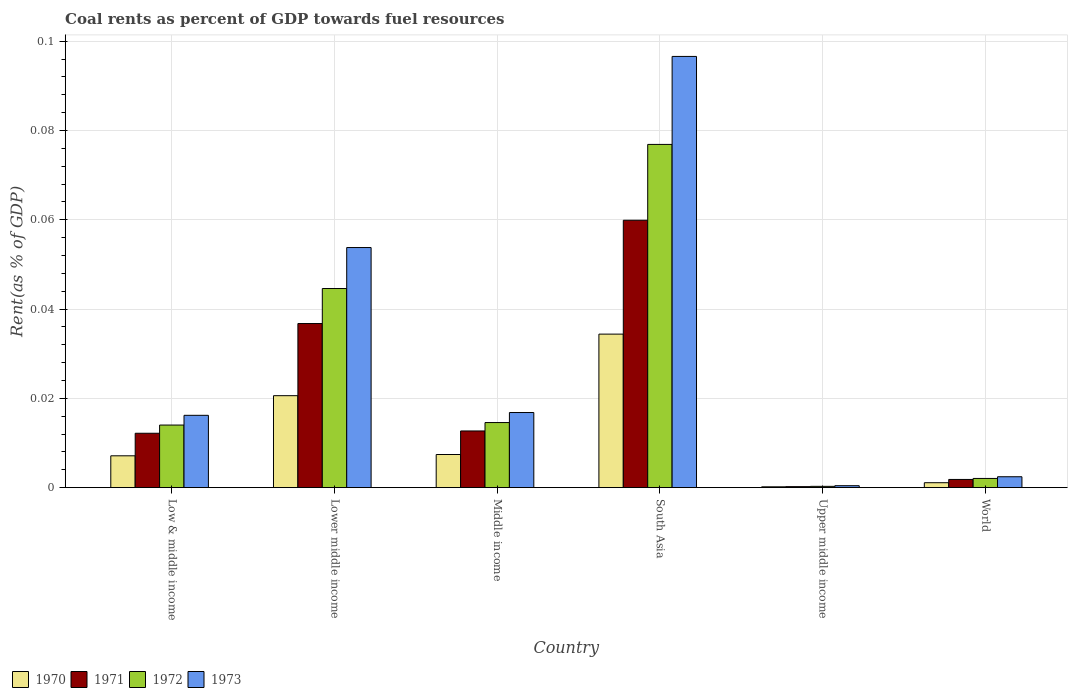How many groups of bars are there?
Offer a terse response. 6. Are the number of bars per tick equal to the number of legend labels?
Offer a very short reply. Yes. How many bars are there on the 3rd tick from the left?
Make the answer very short. 4. What is the label of the 5th group of bars from the left?
Ensure brevity in your answer.  Upper middle income. What is the coal rent in 1973 in South Asia?
Give a very brief answer. 0.1. Across all countries, what is the maximum coal rent in 1971?
Your answer should be very brief. 0.06. Across all countries, what is the minimum coal rent in 1972?
Keep it short and to the point. 0. In which country was the coal rent in 1970 minimum?
Offer a very short reply. Upper middle income. What is the total coal rent in 1973 in the graph?
Provide a succinct answer. 0.19. What is the difference between the coal rent in 1971 in Middle income and that in South Asia?
Provide a succinct answer. -0.05. What is the difference between the coal rent in 1973 in Lower middle income and the coal rent in 1970 in World?
Your answer should be very brief. 0.05. What is the average coal rent in 1973 per country?
Provide a succinct answer. 0.03. What is the difference between the coal rent of/in 1973 and coal rent of/in 1970 in Low & middle income?
Your answer should be very brief. 0.01. In how many countries, is the coal rent in 1971 greater than 0.08 %?
Your answer should be very brief. 0. What is the ratio of the coal rent in 1970 in Low & middle income to that in Lower middle income?
Make the answer very short. 0.35. Is the coal rent in 1972 in Lower middle income less than that in Upper middle income?
Give a very brief answer. No. What is the difference between the highest and the second highest coal rent in 1970?
Your response must be concise. 0.01. What is the difference between the highest and the lowest coal rent in 1971?
Your response must be concise. 0.06. Is the sum of the coal rent in 1970 in Lower middle income and South Asia greater than the maximum coal rent in 1973 across all countries?
Give a very brief answer. No. Is it the case that in every country, the sum of the coal rent in 1971 and coal rent in 1972 is greater than the sum of coal rent in 1970 and coal rent in 1973?
Give a very brief answer. No. What does the 1st bar from the right in South Asia represents?
Offer a terse response. 1973. How many bars are there?
Keep it short and to the point. 24. How many countries are there in the graph?
Your response must be concise. 6. What is the difference between two consecutive major ticks on the Y-axis?
Your answer should be very brief. 0.02. Does the graph contain any zero values?
Provide a short and direct response. No. Where does the legend appear in the graph?
Your answer should be very brief. Bottom left. How many legend labels are there?
Your answer should be very brief. 4. How are the legend labels stacked?
Give a very brief answer. Horizontal. What is the title of the graph?
Your answer should be very brief. Coal rents as percent of GDP towards fuel resources. What is the label or title of the Y-axis?
Your answer should be very brief. Rent(as % of GDP). What is the Rent(as % of GDP) of 1970 in Low & middle income?
Keep it short and to the point. 0.01. What is the Rent(as % of GDP) of 1971 in Low & middle income?
Offer a very short reply. 0.01. What is the Rent(as % of GDP) in 1972 in Low & middle income?
Your answer should be very brief. 0.01. What is the Rent(as % of GDP) in 1973 in Low & middle income?
Offer a very short reply. 0.02. What is the Rent(as % of GDP) in 1970 in Lower middle income?
Offer a very short reply. 0.02. What is the Rent(as % of GDP) in 1971 in Lower middle income?
Provide a short and direct response. 0.04. What is the Rent(as % of GDP) of 1972 in Lower middle income?
Provide a short and direct response. 0.04. What is the Rent(as % of GDP) in 1973 in Lower middle income?
Keep it short and to the point. 0.05. What is the Rent(as % of GDP) in 1970 in Middle income?
Give a very brief answer. 0.01. What is the Rent(as % of GDP) of 1971 in Middle income?
Your answer should be very brief. 0.01. What is the Rent(as % of GDP) in 1972 in Middle income?
Make the answer very short. 0.01. What is the Rent(as % of GDP) in 1973 in Middle income?
Keep it short and to the point. 0.02. What is the Rent(as % of GDP) of 1970 in South Asia?
Make the answer very short. 0.03. What is the Rent(as % of GDP) in 1971 in South Asia?
Make the answer very short. 0.06. What is the Rent(as % of GDP) in 1972 in South Asia?
Ensure brevity in your answer.  0.08. What is the Rent(as % of GDP) of 1973 in South Asia?
Your answer should be very brief. 0.1. What is the Rent(as % of GDP) in 1970 in Upper middle income?
Your answer should be very brief. 0. What is the Rent(as % of GDP) of 1971 in Upper middle income?
Offer a very short reply. 0. What is the Rent(as % of GDP) of 1972 in Upper middle income?
Provide a short and direct response. 0. What is the Rent(as % of GDP) of 1973 in Upper middle income?
Offer a terse response. 0. What is the Rent(as % of GDP) of 1970 in World?
Your response must be concise. 0. What is the Rent(as % of GDP) of 1971 in World?
Ensure brevity in your answer.  0. What is the Rent(as % of GDP) in 1972 in World?
Provide a succinct answer. 0. What is the Rent(as % of GDP) in 1973 in World?
Make the answer very short. 0. Across all countries, what is the maximum Rent(as % of GDP) of 1970?
Your response must be concise. 0.03. Across all countries, what is the maximum Rent(as % of GDP) in 1971?
Provide a short and direct response. 0.06. Across all countries, what is the maximum Rent(as % of GDP) of 1972?
Offer a very short reply. 0.08. Across all countries, what is the maximum Rent(as % of GDP) in 1973?
Keep it short and to the point. 0.1. Across all countries, what is the minimum Rent(as % of GDP) in 1970?
Give a very brief answer. 0. Across all countries, what is the minimum Rent(as % of GDP) in 1971?
Ensure brevity in your answer.  0. Across all countries, what is the minimum Rent(as % of GDP) of 1972?
Provide a succinct answer. 0. Across all countries, what is the minimum Rent(as % of GDP) of 1973?
Offer a very short reply. 0. What is the total Rent(as % of GDP) of 1970 in the graph?
Provide a succinct answer. 0.07. What is the total Rent(as % of GDP) in 1971 in the graph?
Offer a terse response. 0.12. What is the total Rent(as % of GDP) in 1972 in the graph?
Your answer should be compact. 0.15. What is the total Rent(as % of GDP) of 1973 in the graph?
Provide a short and direct response. 0.19. What is the difference between the Rent(as % of GDP) of 1970 in Low & middle income and that in Lower middle income?
Offer a very short reply. -0.01. What is the difference between the Rent(as % of GDP) in 1971 in Low & middle income and that in Lower middle income?
Ensure brevity in your answer.  -0.02. What is the difference between the Rent(as % of GDP) in 1972 in Low & middle income and that in Lower middle income?
Keep it short and to the point. -0.03. What is the difference between the Rent(as % of GDP) in 1973 in Low & middle income and that in Lower middle income?
Provide a short and direct response. -0.04. What is the difference between the Rent(as % of GDP) in 1970 in Low & middle income and that in Middle income?
Offer a very short reply. -0. What is the difference between the Rent(as % of GDP) of 1971 in Low & middle income and that in Middle income?
Provide a succinct answer. -0. What is the difference between the Rent(as % of GDP) in 1972 in Low & middle income and that in Middle income?
Provide a short and direct response. -0. What is the difference between the Rent(as % of GDP) of 1973 in Low & middle income and that in Middle income?
Your response must be concise. -0. What is the difference between the Rent(as % of GDP) in 1970 in Low & middle income and that in South Asia?
Give a very brief answer. -0.03. What is the difference between the Rent(as % of GDP) in 1971 in Low & middle income and that in South Asia?
Give a very brief answer. -0.05. What is the difference between the Rent(as % of GDP) of 1972 in Low & middle income and that in South Asia?
Offer a terse response. -0.06. What is the difference between the Rent(as % of GDP) of 1973 in Low & middle income and that in South Asia?
Offer a terse response. -0.08. What is the difference between the Rent(as % of GDP) of 1970 in Low & middle income and that in Upper middle income?
Offer a terse response. 0.01. What is the difference between the Rent(as % of GDP) of 1971 in Low & middle income and that in Upper middle income?
Keep it short and to the point. 0.01. What is the difference between the Rent(as % of GDP) of 1972 in Low & middle income and that in Upper middle income?
Offer a very short reply. 0.01. What is the difference between the Rent(as % of GDP) in 1973 in Low & middle income and that in Upper middle income?
Make the answer very short. 0.02. What is the difference between the Rent(as % of GDP) in 1970 in Low & middle income and that in World?
Your response must be concise. 0.01. What is the difference between the Rent(as % of GDP) of 1971 in Low & middle income and that in World?
Offer a terse response. 0.01. What is the difference between the Rent(as % of GDP) of 1972 in Low & middle income and that in World?
Offer a very short reply. 0.01. What is the difference between the Rent(as % of GDP) in 1973 in Low & middle income and that in World?
Keep it short and to the point. 0.01. What is the difference between the Rent(as % of GDP) in 1970 in Lower middle income and that in Middle income?
Ensure brevity in your answer.  0.01. What is the difference between the Rent(as % of GDP) in 1971 in Lower middle income and that in Middle income?
Provide a succinct answer. 0.02. What is the difference between the Rent(as % of GDP) in 1972 in Lower middle income and that in Middle income?
Keep it short and to the point. 0.03. What is the difference between the Rent(as % of GDP) in 1973 in Lower middle income and that in Middle income?
Ensure brevity in your answer.  0.04. What is the difference between the Rent(as % of GDP) of 1970 in Lower middle income and that in South Asia?
Provide a succinct answer. -0.01. What is the difference between the Rent(as % of GDP) in 1971 in Lower middle income and that in South Asia?
Give a very brief answer. -0.02. What is the difference between the Rent(as % of GDP) in 1972 in Lower middle income and that in South Asia?
Your answer should be very brief. -0.03. What is the difference between the Rent(as % of GDP) of 1973 in Lower middle income and that in South Asia?
Offer a very short reply. -0.04. What is the difference between the Rent(as % of GDP) of 1970 in Lower middle income and that in Upper middle income?
Offer a terse response. 0.02. What is the difference between the Rent(as % of GDP) of 1971 in Lower middle income and that in Upper middle income?
Make the answer very short. 0.04. What is the difference between the Rent(as % of GDP) in 1972 in Lower middle income and that in Upper middle income?
Make the answer very short. 0.04. What is the difference between the Rent(as % of GDP) in 1973 in Lower middle income and that in Upper middle income?
Provide a short and direct response. 0.05. What is the difference between the Rent(as % of GDP) in 1970 in Lower middle income and that in World?
Your response must be concise. 0.02. What is the difference between the Rent(as % of GDP) in 1971 in Lower middle income and that in World?
Keep it short and to the point. 0.03. What is the difference between the Rent(as % of GDP) in 1972 in Lower middle income and that in World?
Your answer should be very brief. 0.04. What is the difference between the Rent(as % of GDP) in 1973 in Lower middle income and that in World?
Your answer should be very brief. 0.05. What is the difference between the Rent(as % of GDP) of 1970 in Middle income and that in South Asia?
Keep it short and to the point. -0.03. What is the difference between the Rent(as % of GDP) of 1971 in Middle income and that in South Asia?
Provide a short and direct response. -0.05. What is the difference between the Rent(as % of GDP) of 1972 in Middle income and that in South Asia?
Your response must be concise. -0.06. What is the difference between the Rent(as % of GDP) in 1973 in Middle income and that in South Asia?
Offer a terse response. -0.08. What is the difference between the Rent(as % of GDP) in 1970 in Middle income and that in Upper middle income?
Keep it short and to the point. 0.01. What is the difference between the Rent(as % of GDP) of 1971 in Middle income and that in Upper middle income?
Your answer should be very brief. 0.01. What is the difference between the Rent(as % of GDP) in 1972 in Middle income and that in Upper middle income?
Give a very brief answer. 0.01. What is the difference between the Rent(as % of GDP) of 1973 in Middle income and that in Upper middle income?
Your answer should be very brief. 0.02. What is the difference between the Rent(as % of GDP) in 1970 in Middle income and that in World?
Ensure brevity in your answer.  0.01. What is the difference between the Rent(as % of GDP) in 1971 in Middle income and that in World?
Provide a short and direct response. 0.01. What is the difference between the Rent(as % of GDP) in 1972 in Middle income and that in World?
Keep it short and to the point. 0.01. What is the difference between the Rent(as % of GDP) in 1973 in Middle income and that in World?
Keep it short and to the point. 0.01. What is the difference between the Rent(as % of GDP) in 1970 in South Asia and that in Upper middle income?
Offer a very short reply. 0.03. What is the difference between the Rent(as % of GDP) in 1971 in South Asia and that in Upper middle income?
Your answer should be very brief. 0.06. What is the difference between the Rent(as % of GDP) of 1972 in South Asia and that in Upper middle income?
Offer a terse response. 0.08. What is the difference between the Rent(as % of GDP) in 1973 in South Asia and that in Upper middle income?
Provide a succinct answer. 0.1. What is the difference between the Rent(as % of GDP) in 1971 in South Asia and that in World?
Provide a succinct answer. 0.06. What is the difference between the Rent(as % of GDP) in 1972 in South Asia and that in World?
Provide a short and direct response. 0.07. What is the difference between the Rent(as % of GDP) of 1973 in South Asia and that in World?
Offer a terse response. 0.09. What is the difference between the Rent(as % of GDP) of 1970 in Upper middle income and that in World?
Your answer should be very brief. -0. What is the difference between the Rent(as % of GDP) of 1971 in Upper middle income and that in World?
Keep it short and to the point. -0. What is the difference between the Rent(as % of GDP) in 1972 in Upper middle income and that in World?
Provide a succinct answer. -0. What is the difference between the Rent(as % of GDP) of 1973 in Upper middle income and that in World?
Your answer should be very brief. -0. What is the difference between the Rent(as % of GDP) of 1970 in Low & middle income and the Rent(as % of GDP) of 1971 in Lower middle income?
Your answer should be compact. -0.03. What is the difference between the Rent(as % of GDP) of 1970 in Low & middle income and the Rent(as % of GDP) of 1972 in Lower middle income?
Give a very brief answer. -0.04. What is the difference between the Rent(as % of GDP) in 1970 in Low & middle income and the Rent(as % of GDP) in 1973 in Lower middle income?
Offer a very short reply. -0.05. What is the difference between the Rent(as % of GDP) in 1971 in Low & middle income and the Rent(as % of GDP) in 1972 in Lower middle income?
Your response must be concise. -0.03. What is the difference between the Rent(as % of GDP) of 1971 in Low & middle income and the Rent(as % of GDP) of 1973 in Lower middle income?
Ensure brevity in your answer.  -0.04. What is the difference between the Rent(as % of GDP) in 1972 in Low & middle income and the Rent(as % of GDP) in 1973 in Lower middle income?
Provide a short and direct response. -0.04. What is the difference between the Rent(as % of GDP) of 1970 in Low & middle income and the Rent(as % of GDP) of 1971 in Middle income?
Your response must be concise. -0.01. What is the difference between the Rent(as % of GDP) of 1970 in Low & middle income and the Rent(as % of GDP) of 1972 in Middle income?
Provide a short and direct response. -0.01. What is the difference between the Rent(as % of GDP) of 1970 in Low & middle income and the Rent(as % of GDP) of 1973 in Middle income?
Offer a terse response. -0.01. What is the difference between the Rent(as % of GDP) of 1971 in Low & middle income and the Rent(as % of GDP) of 1972 in Middle income?
Offer a very short reply. -0. What is the difference between the Rent(as % of GDP) of 1971 in Low & middle income and the Rent(as % of GDP) of 1973 in Middle income?
Your answer should be very brief. -0. What is the difference between the Rent(as % of GDP) in 1972 in Low & middle income and the Rent(as % of GDP) in 1973 in Middle income?
Make the answer very short. -0. What is the difference between the Rent(as % of GDP) in 1970 in Low & middle income and the Rent(as % of GDP) in 1971 in South Asia?
Offer a terse response. -0.05. What is the difference between the Rent(as % of GDP) in 1970 in Low & middle income and the Rent(as % of GDP) in 1972 in South Asia?
Ensure brevity in your answer.  -0.07. What is the difference between the Rent(as % of GDP) in 1970 in Low & middle income and the Rent(as % of GDP) in 1973 in South Asia?
Keep it short and to the point. -0.09. What is the difference between the Rent(as % of GDP) of 1971 in Low & middle income and the Rent(as % of GDP) of 1972 in South Asia?
Make the answer very short. -0.06. What is the difference between the Rent(as % of GDP) of 1971 in Low & middle income and the Rent(as % of GDP) of 1973 in South Asia?
Give a very brief answer. -0.08. What is the difference between the Rent(as % of GDP) in 1972 in Low & middle income and the Rent(as % of GDP) in 1973 in South Asia?
Provide a succinct answer. -0.08. What is the difference between the Rent(as % of GDP) of 1970 in Low & middle income and the Rent(as % of GDP) of 1971 in Upper middle income?
Provide a succinct answer. 0.01. What is the difference between the Rent(as % of GDP) of 1970 in Low & middle income and the Rent(as % of GDP) of 1972 in Upper middle income?
Your answer should be very brief. 0.01. What is the difference between the Rent(as % of GDP) in 1970 in Low & middle income and the Rent(as % of GDP) in 1973 in Upper middle income?
Keep it short and to the point. 0.01. What is the difference between the Rent(as % of GDP) of 1971 in Low & middle income and the Rent(as % of GDP) of 1972 in Upper middle income?
Ensure brevity in your answer.  0.01. What is the difference between the Rent(as % of GDP) of 1971 in Low & middle income and the Rent(as % of GDP) of 1973 in Upper middle income?
Ensure brevity in your answer.  0.01. What is the difference between the Rent(as % of GDP) in 1972 in Low & middle income and the Rent(as % of GDP) in 1973 in Upper middle income?
Offer a very short reply. 0.01. What is the difference between the Rent(as % of GDP) in 1970 in Low & middle income and the Rent(as % of GDP) in 1971 in World?
Your answer should be compact. 0.01. What is the difference between the Rent(as % of GDP) of 1970 in Low & middle income and the Rent(as % of GDP) of 1972 in World?
Make the answer very short. 0.01. What is the difference between the Rent(as % of GDP) in 1970 in Low & middle income and the Rent(as % of GDP) in 1973 in World?
Offer a very short reply. 0. What is the difference between the Rent(as % of GDP) of 1971 in Low & middle income and the Rent(as % of GDP) of 1972 in World?
Offer a terse response. 0.01. What is the difference between the Rent(as % of GDP) of 1971 in Low & middle income and the Rent(as % of GDP) of 1973 in World?
Offer a very short reply. 0.01. What is the difference between the Rent(as % of GDP) of 1972 in Low & middle income and the Rent(as % of GDP) of 1973 in World?
Your response must be concise. 0.01. What is the difference between the Rent(as % of GDP) in 1970 in Lower middle income and the Rent(as % of GDP) in 1971 in Middle income?
Your answer should be compact. 0.01. What is the difference between the Rent(as % of GDP) of 1970 in Lower middle income and the Rent(as % of GDP) of 1972 in Middle income?
Provide a succinct answer. 0.01. What is the difference between the Rent(as % of GDP) in 1970 in Lower middle income and the Rent(as % of GDP) in 1973 in Middle income?
Your answer should be compact. 0. What is the difference between the Rent(as % of GDP) in 1971 in Lower middle income and the Rent(as % of GDP) in 1972 in Middle income?
Provide a succinct answer. 0.02. What is the difference between the Rent(as % of GDP) of 1971 in Lower middle income and the Rent(as % of GDP) of 1973 in Middle income?
Provide a succinct answer. 0.02. What is the difference between the Rent(as % of GDP) in 1972 in Lower middle income and the Rent(as % of GDP) in 1973 in Middle income?
Make the answer very short. 0.03. What is the difference between the Rent(as % of GDP) of 1970 in Lower middle income and the Rent(as % of GDP) of 1971 in South Asia?
Give a very brief answer. -0.04. What is the difference between the Rent(as % of GDP) of 1970 in Lower middle income and the Rent(as % of GDP) of 1972 in South Asia?
Your answer should be very brief. -0.06. What is the difference between the Rent(as % of GDP) of 1970 in Lower middle income and the Rent(as % of GDP) of 1973 in South Asia?
Provide a short and direct response. -0.08. What is the difference between the Rent(as % of GDP) of 1971 in Lower middle income and the Rent(as % of GDP) of 1972 in South Asia?
Your answer should be compact. -0.04. What is the difference between the Rent(as % of GDP) of 1971 in Lower middle income and the Rent(as % of GDP) of 1973 in South Asia?
Keep it short and to the point. -0.06. What is the difference between the Rent(as % of GDP) in 1972 in Lower middle income and the Rent(as % of GDP) in 1973 in South Asia?
Make the answer very short. -0.05. What is the difference between the Rent(as % of GDP) in 1970 in Lower middle income and the Rent(as % of GDP) in 1971 in Upper middle income?
Make the answer very short. 0.02. What is the difference between the Rent(as % of GDP) in 1970 in Lower middle income and the Rent(as % of GDP) in 1972 in Upper middle income?
Your response must be concise. 0.02. What is the difference between the Rent(as % of GDP) of 1970 in Lower middle income and the Rent(as % of GDP) of 1973 in Upper middle income?
Ensure brevity in your answer.  0.02. What is the difference between the Rent(as % of GDP) in 1971 in Lower middle income and the Rent(as % of GDP) in 1972 in Upper middle income?
Make the answer very short. 0.04. What is the difference between the Rent(as % of GDP) of 1971 in Lower middle income and the Rent(as % of GDP) of 1973 in Upper middle income?
Your response must be concise. 0.04. What is the difference between the Rent(as % of GDP) of 1972 in Lower middle income and the Rent(as % of GDP) of 1973 in Upper middle income?
Provide a short and direct response. 0.04. What is the difference between the Rent(as % of GDP) in 1970 in Lower middle income and the Rent(as % of GDP) in 1971 in World?
Make the answer very short. 0.02. What is the difference between the Rent(as % of GDP) of 1970 in Lower middle income and the Rent(as % of GDP) of 1972 in World?
Your response must be concise. 0.02. What is the difference between the Rent(as % of GDP) of 1970 in Lower middle income and the Rent(as % of GDP) of 1973 in World?
Your response must be concise. 0.02. What is the difference between the Rent(as % of GDP) in 1971 in Lower middle income and the Rent(as % of GDP) in 1972 in World?
Provide a succinct answer. 0.03. What is the difference between the Rent(as % of GDP) in 1971 in Lower middle income and the Rent(as % of GDP) in 1973 in World?
Offer a very short reply. 0.03. What is the difference between the Rent(as % of GDP) in 1972 in Lower middle income and the Rent(as % of GDP) in 1973 in World?
Provide a succinct answer. 0.04. What is the difference between the Rent(as % of GDP) in 1970 in Middle income and the Rent(as % of GDP) in 1971 in South Asia?
Give a very brief answer. -0.05. What is the difference between the Rent(as % of GDP) in 1970 in Middle income and the Rent(as % of GDP) in 1972 in South Asia?
Your response must be concise. -0.07. What is the difference between the Rent(as % of GDP) in 1970 in Middle income and the Rent(as % of GDP) in 1973 in South Asia?
Provide a succinct answer. -0.09. What is the difference between the Rent(as % of GDP) in 1971 in Middle income and the Rent(as % of GDP) in 1972 in South Asia?
Your answer should be compact. -0.06. What is the difference between the Rent(as % of GDP) of 1971 in Middle income and the Rent(as % of GDP) of 1973 in South Asia?
Your answer should be compact. -0.08. What is the difference between the Rent(as % of GDP) of 1972 in Middle income and the Rent(as % of GDP) of 1973 in South Asia?
Ensure brevity in your answer.  -0.08. What is the difference between the Rent(as % of GDP) of 1970 in Middle income and the Rent(as % of GDP) of 1971 in Upper middle income?
Give a very brief answer. 0.01. What is the difference between the Rent(as % of GDP) of 1970 in Middle income and the Rent(as % of GDP) of 1972 in Upper middle income?
Your answer should be very brief. 0.01. What is the difference between the Rent(as % of GDP) of 1970 in Middle income and the Rent(as % of GDP) of 1973 in Upper middle income?
Keep it short and to the point. 0.01. What is the difference between the Rent(as % of GDP) in 1971 in Middle income and the Rent(as % of GDP) in 1972 in Upper middle income?
Offer a terse response. 0.01. What is the difference between the Rent(as % of GDP) of 1971 in Middle income and the Rent(as % of GDP) of 1973 in Upper middle income?
Your answer should be very brief. 0.01. What is the difference between the Rent(as % of GDP) of 1972 in Middle income and the Rent(as % of GDP) of 1973 in Upper middle income?
Your response must be concise. 0.01. What is the difference between the Rent(as % of GDP) in 1970 in Middle income and the Rent(as % of GDP) in 1971 in World?
Provide a short and direct response. 0.01. What is the difference between the Rent(as % of GDP) in 1970 in Middle income and the Rent(as % of GDP) in 1972 in World?
Give a very brief answer. 0.01. What is the difference between the Rent(as % of GDP) in 1970 in Middle income and the Rent(as % of GDP) in 1973 in World?
Offer a very short reply. 0.01. What is the difference between the Rent(as % of GDP) of 1971 in Middle income and the Rent(as % of GDP) of 1972 in World?
Ensure brevity in your answer.  0.01. What is the difference between the Rent(as % of GDP) in 1971 in Middle income and the Rent(as % of GDP) in 1973 in World?
Give a very brief answer. 0.01. What is the difference between the Rent(as % of GDP) of 1972 in Middle income and the Rent(as % of GDP) of 1973 in World?
Offer a terse response. 0.01. What is the difference between the Rent(as % of GDP) in 1970 in South Asia and the Rent(as % of GDP) in 1971 in Upper middle income?
Provide a succinct answer. 0.03. What is the difference between the Rent(as % of GDP) in 1970 in South Asia and the Rent(as % of GDP) in 1972 in Upper middle income?
Your answer should be compact. 0.03. What is the difference between the Rent(as % of GDP) of 1970 in South Asia and the Rent(as % of GDP) of 1973 in Upper middle income?
Your response must be concise. 0.03. What is the difference between the Rent(as % of GDP) of 1971 in South Asia and the Rent(as % of GDP) of 1972 in Upper middle income?
Your response must be concise. 0.06. What is the difference between the Rent(as % of GDP) of 1971 in South Asia and the Rent(as % of GDP) of 1973 in Upper middle income?
Offer a very short reply. 0.06. What is the difference between the Rent(as % of GDP) of 1972 in South Asia and the Rent(as % of GDP) of 1973 in Upper middle income?
Keep it short and to the point. 0.08. What is the difference between the Rent(as % of GDP) in 1970 in South Asia and the Rent(as % of GDP) in 1971 in World?
Offer a terse response. 0.03. What is the difference between the Rent(as % of GDP) of 1970 in South Asia and the Rent(as % of GDP) of 1972 in World?
Your answer should be compact. 0.03. What is the difference between the Rent(as % of GDP) of 1970 in South Asia and the Rent(as % of GDP) of 1973 in World?
Make the answer very short. 0.03. What is the difference between the Rent(as % of GDP) in 1971 in South Asia and the Rent(as % of GDP) in 1972 in World?
Your answer should be compact. 0.06. What is the difference between the Rent(as % of GDP) of 1971 in South Asia and the Rent(as % of GDP) of 1973 in World?
Your answer should be very brief. 0.06. What is the difference between the Rent(as % of GDP) in 1972 in South Asia and the Rent(as % of GDP) in 1973 in World?
Give a very brief answer. 0.07. What is the difference between the Rent(as % of GDP) of 1970 in Upper middle income and the Rent(as % of GDP) of 1971 in World?
Your answer should be very brief. -0. What is the difference between the Rent(as % of GDP) of 1970 in Upper middle income and the Rent(as % of GDP) of 1972 in World?
Provide a succinct answer. -0. What is the difference between the Rent(as % of GDP) in 1970 in Upper middle income and the Rent(as % of GDP) in 1973 in World?
Provide a short and direct response. -0. What is the difference between the Rent(as % of GDP) of 1971 in Upper middle income and the Rent(as % of GDP) of 1972 in World?
Your answer should be compact. -0. What is the difference between the Rent(as % of GDP) in 1971 in Upper middle income and the Rent(as % of GDP) in 1973 in World?
Your answer should be very brief. -0. What is the difference between the Rent(as % of GDP) in 1972 in Upper middle income and the Rent(as % of GDP) in 1973 in World?
Give a very brief answer. -0. What is the average Rent(as % of GDP) of 1970 per country?
Make the answer very short. 0.01. What is the average Rent(as % of GDP) of 1971 per country?
Your answer should be compact. 0.02. What is the average Rent(as % of GDP) in 1972 per country?
Keep it short and to the point. 0.03. What is the average Rent(as % of GDP) in 1973 per country?
Give a very brief answer. 0.03. What is the difference between the Rent(as % of GDP) of 1970 and Rent(as % of GDP) of 1971 in Low & middle income?
Provide a short and direct response. -0.01. What is the difference between the Rent(as % of GDP) in 1970 and Rent(as % of GDP) in 1972 in Low & middle income?
Your answer should be very brief. -0.01. What is the difference between the Rent(as % of GDP) in 1970 and Rent(as % of GDP) in 1973 in Low & middle income?
Keep it short and to the point. -0.01. What is the difference between the Rent(as % of GDP) in 1971 and Rent(as % of GDP) in 1972 in Low & middle income?
Make the answer very short. -0. What is the difference between the Rent(as % of GDP) in 1971 and Rent(as % of GDP) in 1973 in Low & middle income?
Offer a very short reply. -0. What is the difference between the Rent(as % of GDP) of 1972 and Rent(as % of GDP) of 1973 in Low & middle income?
Your response must be concise. -0. What is the difference between the Rent(as % of GDP) in 1970 and Rent(as % of GDP) in 1971 in Lower middle income?
Your answer should be very brief. -0.02. What is the difference between the Rent(as % of GDP) of 1970 and Rent(as % of GDP) of 1972 in Lower middle income?
Your answer should be very brief. -0.02. What is the difference between the Rent(as % of GDP) of 1970 and Rent(as % of GDP) of 1973 in Lower middle income?
Keep it short and to the point. -0.03. What is the difference between the Rent(as % of GDP) of 1971 and Rent(as % of GDP) of 1972 in Lower middle income?
Give a very brief answer. -0.01. What is the difference between the Rent(as % of GDP) of 1971 and Rent(as % of GDP) of 1973 in Lower middle income?
Make the answer very short. -0.02. What is the difference between the Rent(as % of GDP) in 1972 and Rent(as % of GDP) in 1973 in Lower middle income?
Keep it short and to the point. -0.01. What is the difference between the Rent(as % of GDP) in 1970 and Rent(as % of GDP) in 1971 in Middle income?
Your answer should be compact. -0.01. What is the difference between the Rent(as % of GDP) of 1970 and Rent(as % of GDP) of 1972 in Middle income?
Ensure brevity in your answer.  -0.01. What is the difference between the Rent(as % of GDP) in 1970 and Rent(as % of GDP) in 1973 in Middle income?
Ensure brevity in your answer.  -0.01. What is the difference between the Rent(as % of GDP) in 1971 and Rent(as % of GDP) in 1972 in Middle income?
Offer a terse response. -0. What is the difference between the Rent(as % of GDP) of 1971 and Rent(as % of GDP) of 1973 in Middle income?
Your answer should be very brief. -0. What is the difference between the Rent(as % of GDP) in 1972 and Rent(as % of GDP) in 1973 in Middle income?
Offer a terse response. -0. What is the difference between the Rent(as % of GDP) in 1970 and Rent(as % of GDP) in 1971 in South Asia?
Ensure brevity in your answer.  -0.03. What is the difference between the Rent(as % of GDP) of 1970 and Rent(as % of GDP) of 1972 in South Asia?
Your answer should be compact. -0.04. What is the difference between the Rent(as % of GDP) of 1970 and Rent(as % of GDP) of 1973 in South Asia?
Make the answer very short. -0.06. What is the difference between the Rent(as % of GDP) of 1971 and Rent(as % of GDP) of 1972 in South Asia?
Give a very brief answer. -0.02. What is the difference between the Rent(as % of GDP) of 1971 and Rent(as % of GDP) of 1973 in South Asia?
Keep it short and to the point. -0.04. What is the difference between the Rent(as % of GDP) of 1972 and Rent(as % of GDP) of 1973 in South Asia?
Offer a terse response. -0.02. What is the difference between the Rent(as % of GDP) of 1970 and Rent(as % of GDP) of 1972 in Upper middle income?
Provide a succinct answer. -0. What is the difference between the Rent(as % of GDP) of 1970 and Rent(as % of GDP) of 1973 in Upper middle income?
Provide a short and direct response. -0. What is the difference between the Rent(as % of GDP) of 1971 and Rent(as % of GDP) of 1972 in Upper middle income?
Provide a short and direct response. -0. What is the difference between the Rent(as % of GDP) of 1971 and Rent(as % of GDP) of 1973 in Upper middle income?
Your answer should be compact. -0. What is the difference between the Rent(as % of GDP) in 1972 and Rent(as % of GDP) in 1973 in Upper middle income?
Offer a terse response. -0. What is the difference between the Rent(as % of GDP) in 1970 and Rent(as % of GDP) in 1971 in World?
Provide a short and direct response. -0. What is the difference between the Rent(as % of GDP) in 1970 and Rent(as % of GDP) in 1972 in World?
Your answer should be very brief. -0. What is the difference between the Rent(as % of GDP) of 1970 and Rent(as % of GDP) of 1973 in World?
Provide a short and direct response. -0. What is the difference between the Rent(as % of GDP) in 1971 and Rent(as % of GDP) in 1972 in World?
Give a very brief answer. -0. What is the difference between the Rent(as % of GDP) of 1971 and Rent(as % of GDP) of 1973 in World?
Ensure brevity in your answer.  -0. What is the difference between the Rent(as % of GDP) of 1972 and Rent(as % of GDP) of 1973 in World?
Offer a very short reply. -0. What is the ratio of the Rent(as % of GDP) in 1970 in Low & middle income to that in Lower middle income?
Offer a very short reply. 0.35. What is the ratio of the Rent(as % of GDP) in 1971 in Low & middle income to that in Lower middle income?
Your response must be concise. 0.33. What is the ratio of the Rent(as % of GDP) of 1972 in Low & middle income to that in Lower middle income?
Offer a very short reply. 0.31. What is the ratio of the Rent(as % of GDP) in 1973 in Low & middle income to that in Lower middle income?
Offer a very short reply. 0.3. What is the ratio of the Rent(as % of GDP) in 1970 in Low & middle income to that in Middle income?
Your answer should be compact. 0.96. What is the ratio of the Rent(as % of GDP) in 1971 in Low & middle income to that in Middle income?
Offer a very short reply. 0.96. What is the ratio of the Rent(as % of GDP) of 1972 in Low & middle income to that in Middle income?
Your response must be concise. 0.96. What is the ratio of the Rent(as % of GDP) of 1973 in Low & middle income to that in Middle income?
Keep it short and to the point. 0.96. What is the ratio of the Rent(as % of GDP) of 1970 in Low & middle income to that in South Asia?
Your response must be concise. 0.21. What is the ratio of the Rent(as % of GDP) of 1971 in Low & middle income to that in South Asia?
Make the answer very short. 0.2. What is the ratio of the Rent(as % of GDP) of 1972 in Low & middle income to that in South Asia?
Your response must be concise. 0.18. What is the ratio of the Rent(as % of GDP) of 1973 in Low & middle income to that in South Asia?
Your answer should be compact. 0.17. What is the ratio of the Rent(as % of GDP) in 1970 in Low & middle income to that in Upper middle income?
Offer a very short reply. 38.77. What is the ratio of the Rent(as % of GDP) of 1971 in Low & middle income to that in Upper middle income?
Your answer should be compact. 55.66. What is the ratio of the Rent(as % of GDP) in 1972 in Low & middle income to that in Upper middle income?
Provide a succinct answer. 49.28. What is the ratio of the Rent(as % of GDP) in 1973 in Low & middle income to that in Upper middle income?
Provide a short and direct response. 37.59. What is the ratio of the Rent(as % of GDP) in 1970 in Low & middle income to that in World?
Keep it short and to the point. 6.48. What is the ratio of the Rent(as % of GDP) of 1971 in Low & middle income to that in World?
Your answer should be compact. 6.65. What is the ratio of the Rent(as % of GDP) in 1972 in Low & middle income to that in World?
Offer a very short reply. 6.82. What is the ratio of the Rent(as % of GDP) in 1973 in Low & middle income to that in World?
Give a very brief answer. 6.65. What is the ratio of the Rent(as % of GDP) in 1970 in Lower middle income to that in Middle income?
Keep it short and to the point. 2.78. What is the ratio of the Rent(as % of GDP) in 1971 in Lower middle income to that in Middle income?
Provide a short and direct response. 2.9. What is the ratio of the Rent(as % of GDP) in 1972 in Lower middle income to that in Middle income?
Your answer should be very brief. 3.06. What is the ratio of the Rent(as % of GDP) in 1973 in Lower middle income to that in Middle income?
Give a very brief answer. 3.2. What is the ratio of the Rent(as % of GDP) in 1970 in Lower middle income to that in South Asia?
Ensure brevity in your answer.  0.6. What is the ratio of the Rent(as % of GDP) of 1971 in Lower middle income to that in South Asia?
Make the answer very short. 0.61. What is the ratio of the Rent(as % of GDP) in 1972 in Lower middle income to that in South Asia?
Keep it short and to the point. 0.58. What is the ratio of the Rent(as % of GDP) of 1973 in Lower middle income to that in South Asia?
Give a very brief answer. 0.56. What is the ratio of the Rent(as % of GDP) in 1970 in Lower middle income to that in Upper middle income?
Keep it short and to the point. 112.03. What is the ratio of the Rent(as % of GDP) of 1971 in Lower middle income to that in Upper middle income?
Ensure brevity in your answer.  167.98. What is the ratio of the Rent(as % of GDP) of 1972 in Lower middle income to that in Upper middle income?
Ensure brevity in your answer.  156.82. What is the ratio of the Rent(as % of GDP) of 1973 in Lower middle income to that in Upper middle income?
Provide a short and direct response. 124.82. What is the ratio of the Rent(as % of GDP) in 1970 in Lower middle income to that in World?
Your answer should be compact. 18.71. What is the ratio of the Rent(as % of GDP) of 1971 in Lower middle income to that in World?
Offer a very short reply. 20.06. What is the ratio of the Rent(as % of GDP) of 1972 in Lower middle income to that in World?
Your answer should be compact. 21.7. What is the ratio of the Rent(as % of GDP) of 1973 in Lower middle income to that in World?
Offer a terse response. 22.07. What is the ratio of the Rent(as % of GDP) in 1970 in Middle income to that in South Asia?
Your answer should be very brief. 0.22. What is the ratio of the Rent(as % of GDP) of 1971 in Middle income to that in South Asia?
Provide a short and direct response. 0.21. What is the ratio of the Rent(as % of GDP) in 1972 in Middle income to that in South Asia?
Offer a terse response. 0.19. What is the ratio of the Rent(as % of GDP) in 1973 in Middle income to that in South Asia?
Offer a terse response. 0.17. What is the ratio of the Rent(as % of GDP) in 1970 in Middle income to that in Upper middle income?
Make the answer very short. 40.36. What is the ratio of the Rent(as % of GDP) in 1971 in Middle income to that in Upper middle income?
Your answer should be very brief. 58.01. What is the ratio of the Rent(as % of GDP) of 1972 in Middle income to that in Upper middle income?
Offer a very short reply. 51.25. What is the ratio of the Rent(as % of GDP) in 1973 in Middle income to that in Upper middle income?
Give a very brief answer. 39.04. What is the ratio of the Rent(as % of GDP) in 1970 in Middle income to that in World?
Your answer should be very brief. 6.74. What is the ratio of the Rent(as % of GDP) in 1971 in Middle income to that in World?
Keep it short and to the point. 6.93. What is the ratio of the Rent(as % of GDP) of 1972 in Middle income to that in World?
Provide a short and direct response. 7.09. What is the ratio of the Rent(as % of GDP) in 1973 in Middle income to that in World?
Ensure brevity in your answer.  6.91. What is the ratio of the Rent(as % of GDP) of 1970 in South Asia to that in Upper middle income?
Your response must be concise. 187.05. What is the ratio of the Rent(as % of GDP) of 1971 in South Asia to that in Upper middle income?
Your answer should be compact. 273.74. What is the ratio of the Rent(as % of GDP) in 1972 in South Asia to that in Upper middle income?
Offer a terse response. 270.32. What is the ratio of the Rent(as % of GDP) in 1973 in South Asia to that in Upper middle income?
Keep it short and to the point. 224.18. What is the ratio of the Rent(as % of GDP) in 1970 in South Asia to that in World?
Your response must be concise. 31.24. What is the ratio of the Rent(as % of GDP) in 1971 in South Asia to that in World?
Give a very brief answer. 32.69. What is the ratio of the Rent(as % of GDP) in 1972 in South Asia to that in World?
Your response must be concise. 37.41. What is the ratio of the Rent(as % of GDP) of 1973 in South Asia to that in World?
Provide a short and direct response. 39.65. What is the ratio of the Rent(as % of GDP) of 1970 in Upper middle income to that in World?
Ensure brevity in your answer.  0.17. What is the ratio of the Rent(as % of GDP) of 1971 in Upper middle income to that in World?
Keep it short and to the point. 0.12. What is the ratio of the Rent(as % of GDP) in 1972 in Upper middle income to that in World?
Your answer should be very brief. 0.14. What is the ratio of the Rent(as % of GDP) of 1973 in Upper middle income to that in World?
Offer a very short reply. 0.18. What is the difference between the highest and the second highest Rent(as % of GDP) of 1970?
Your answer should be very brief. 0.01. What is the difference between the highest and the second highest Rent(as % of GDP) of 1971?
Your answer should be very brief. 0.02. What is the difference between the highest and the second highest Rent(as % of GDP) of 1972?
Keep it short and to the point. 0.03. What is the difference between the highest and the second highest Rent(as % of GDP) of 1973?
Offer a terse response. 0.04. What is the difference between the highest and the lowest Rent(as % of GDP) in 1970?
Give a very brief answer. 0.03. What is the difference between the highest and the lowest Rent(as % of GDP) in 1971?
Offer a very short reply. 0.06. What is the difference between the highest and the lowest Rent(as % of GDP) of 1972?
Provide a short and direct response. 0.08. What is the difference between the highest and the lowest Rent(as % of GDP) in 1973?
Your answer should be very brief. 0.1. 